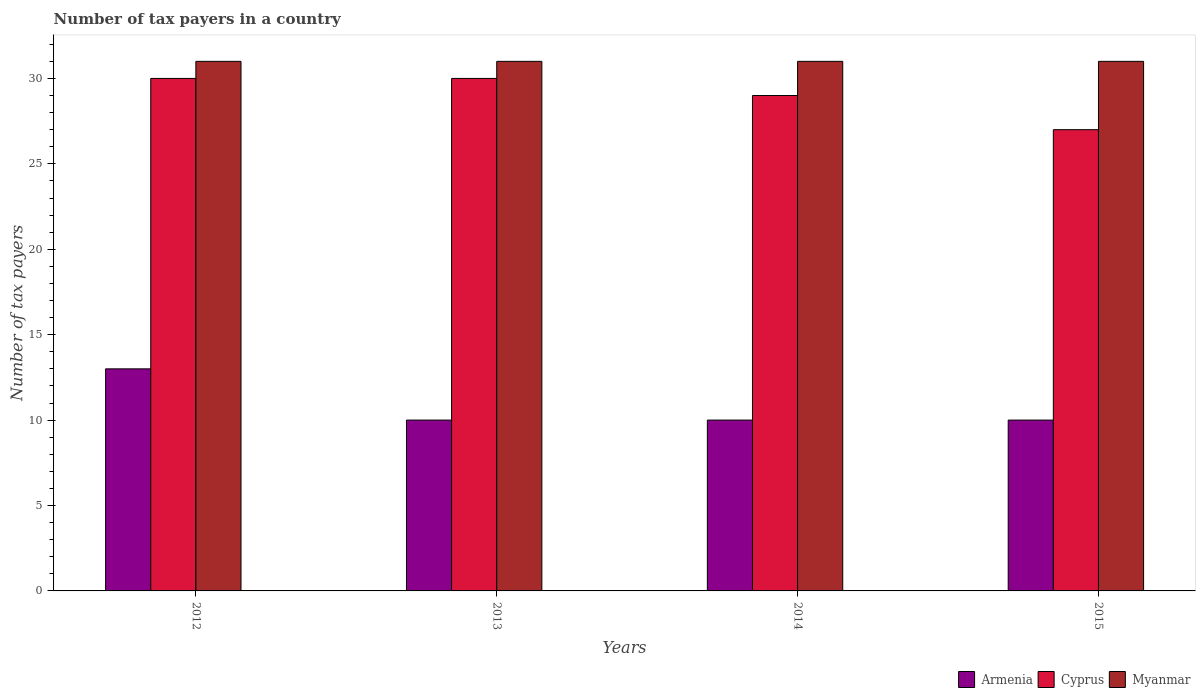How many groups of bars are there?
Ensure brevity in your answer.  4. How many bars are there on the 1st tick from the left?
Offer a very short reply. 3. In how many cases, is the number of bars for a given year not equal to the number of legend labels?
Your answer should be compact. 0. Across all years, what is the minimum number of tax payers in in Armenia?
Offer a terse response. 10. In which year was the number of tax payers in in Cyprus minimum?
Keep it short and to the point. 2015. What is the total number of tax payers in in Armenia in the graph?
Your response must be concise. 43. In the year 2012, what is the difference between the number of tax payers in in Myanmar and number of tax payers in in Armenia?
Your response must be concise. 18. What is the ratio of the number of tax payers in in Myanmar in 2014 to that in 2015?
Offer a very short reply. 1. Is the number of tax payers in in Myanmar in 2012 less than that in 2013?
Keep it short and to the point. No. What is the difference between the highest and the lowest number of tax payers in in Armenia?
Your response must be concise. 3. Is the sum of the number of tax payers in in Armenia in 2012 and 2015 greater than the maximum number of tax payers in in Cyprus across all years?
Give a very brief answer. No. What does the 3rd bar from the left in 2012 represents?
Your answer should be very brief. Myanmar. What does the 1st bar from the right in 2013 represents?
Provide a succinct answer. Myanmar. Is it the case that in every year, the sum of the number of tax payers in in Cyprus and number of tax payers in in Armenia is greater than the number of tax payers in in Myanmar?
Give a very brief answer. Yes. Are the values on the major ticks of Y-axis written in scientific E-notation?
Give a very brief answer. No. Where does the legend appear in the graph?
Provide a short and direct response. Bottom right. How many legend labels are there?
Offer a very short reply. 3. What is the title of the graph?
Ensure brevity in your answer.  Number of tax payers in a country. Does "Libya" appear as one of the legend labels in the graph?
Make the answer very short. No. What is the label or title of the X-axis?
Offer a very short reply. Years. What is the label or title of the Y-axis?
Your response must be concise. Number of tax payers. What is the Number of tax payers in Cyprus in 2012?
Keep it short and to the point. 30. What is the Number of tax payers of Cyprus in 2014?
Your answer should be very brief. 29. What is the Number of tax payers in Cyprus in 2015?
Your answer should be compact. 27. What is the Number of tax payers in Myanmar in 2015?
Provide a short and direct response. 31. What is the total Number of tax payers in Cyprus in the graph?
Keep it short and to the point. 116. What is the total Number of tax payers in Myanmar in the graph?
Keep it short and to the point. 124. What is the difference between the Number of tax payers of Armenia in 2012 and that in 2013?
Provide a short and direct response. 3. What is the difference between the Number of tax payers of Cyprus in 2012 and that in 2013?
Offer a very short reply. 0. What is the difference between the Number of tax payers of Myanmar in 2012 and that in 2013?
Offer a terse response. 0. What is the difference between the Number of tax payers of Armenia in 2012 and that in 2014?
Make the answer very short. 3. What is the difference between the Number of tax payers in Armenia in 2012 and that in 2015?
Provide a short and direct response. 3. What is the difference between the Number of tax payers of Cyprus in 2012 and that in 2015?
Offer a terse response. 3. What is the difference between the Number of tax payers of Armenia in 2013 and that in 2015?
Offer a terse response. 0. What is the difference between the Number of tax payers in Myanmar in 2013 and that in 2015?
Give a very brief answer. 0. What is the difference between the Number of tax payers in Cyprus in 2014 and that in 2015?
Your response must be concise. 2. What is the difference between the Number of tax payers of Armenia in 2012 and the Number of tax payers of Cyprus in 2013?
Offer a very short reply. -17. What is the difference between the Number of tax payers of Armenia in 2012 and the Number of tax payers of Myanmar in 2013?
Your answer should be compact. -18. What is the difference between the Number of tax payers of Armenia in 2012 and the Number of tax payers of Cyprus in 2014?
Your answer should be very brief. -16. What is the difference between the Number of tax payers of Armenia in 2012 and the Number of tax payers of Myanmar in 2014?
Give a very brief answer. -18. What is the difference between the Number of tax payers of Cyprus in 2012 and the Number of tax payers of Myanmar in 2014?
Offer a very short reply. -1. What is the difference between the Number of tax payers of Armenia in 2012 and the Number of tax payers of Cyprus in 2015?
Your answer should be very brief. -14. What is the difference between the Number of tax payers in Armenia in 2012 and the Number of tax payers in Myanmar in 2015?
Ensure brevity in your answer.  -18. What is the difference between the Number of tax payers in Armenia in 2013 and the Number of tax payers in Cyprus in 2015?
Keep it short and to the point. -17. What is the difference between the Number of tax payers in Armenia in 2013 and the Number of tax payers in Myanmar in 2015?
Ensure brevity in your answer.  -21. What is the difference between the Number of tax payers of Armenia in 2014 and the Number of tax payers of Myanmar in 2015?
Keep it short and to the point. -21. What is the difference between the Number of tax payers of Cyprus in 2014 and the Number of tax payers of Myanmar in 2015?
Your answer should be compact. -2. What is the average Number of tax payers of Armenia per year?
Make the answer very short. 10.75. In the year 2012, what is the difference between the Number of tax payers in Armenia and Number of tax payers in Cyprus?
Make the answer very short. -17. In the year 2012, what is the difference between the Number of tax payers in Cyprus and Number of tax payers in Myanmar?
Your response must be concise. -1. In the year 2013, what is the difference between the Number of tax payers in Armenia and Number of tax payers in Myanmar?
Offer a terse response. -21. In the year 2014, what is the difference between the Number of tax payers of Armenia and Number of tax payers of Cyprus?
Offer a very short reply. -19. In the year 2014, what is the difference between the Number of tax payers in Cyprus and Number of tax payers in Myanmar?
Offer a very short reply. -2. What is the ratio of the Number of tax payers in Myanmar in 2012 to that in 2013?
Make the answer very short. 1. What is the ratio of the Number of tax payers in Armenia in 2012 to that in 2014?
Your answer should be very brief. 1.3. What is the ratio of the Number of tax payers of Cyprus in 2012 to that in 2014?
Give a very brief answer. 1.03. What is the ratio of the Number of tax payers of Myanmar in 2012 to that in 2014?
Offer a very short reply. 1. What is the ratio of the Number of tax payers in Myanmar in 2012 to that in 2015?
Your answer should be very brief. 1. What is the ratio of the Number of tax payers of Armenia in 2013 to that in 2014?
Your answer should be very brief. 1. What is the ratio of the Number of tax payers in Cyprus in 2013 to that in 2014?
Give a very brief answer. 1.03. What is the ratio of the Number of tax payers of Myanmar in 2013 to that in 2014?
Your response must be concise. 1. What is the ratio of the Number of tax payers in Armenia in 2013 to that in 2015?
Your response must be concise. 1. What is the ratio of the Number of tax payers in Cyprus in 2014 to that in 2015?
Offer a very short reply. 1.07. What is the difference between the highest and the second highest Number of tax payers of Myanmar?
Your answer should be very brief. 0. What is the difference between the highest and the lowest Number of tax payers in Armenia?
Offer a terse response. 3. What is the difference between the highest and the lowest Number of tax payers of Myanmar?
Give a very brief answer. 0. 